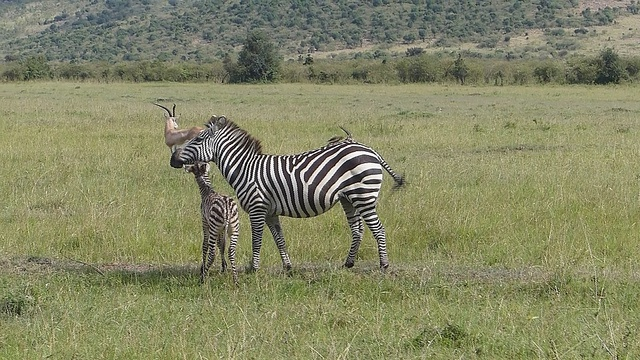Describe the objects in this image and their specific colors. I can see zebra in gray, black, lightgray, and darkgray tones and zebra in gray, olive, black, and darkgray tones in this image. 